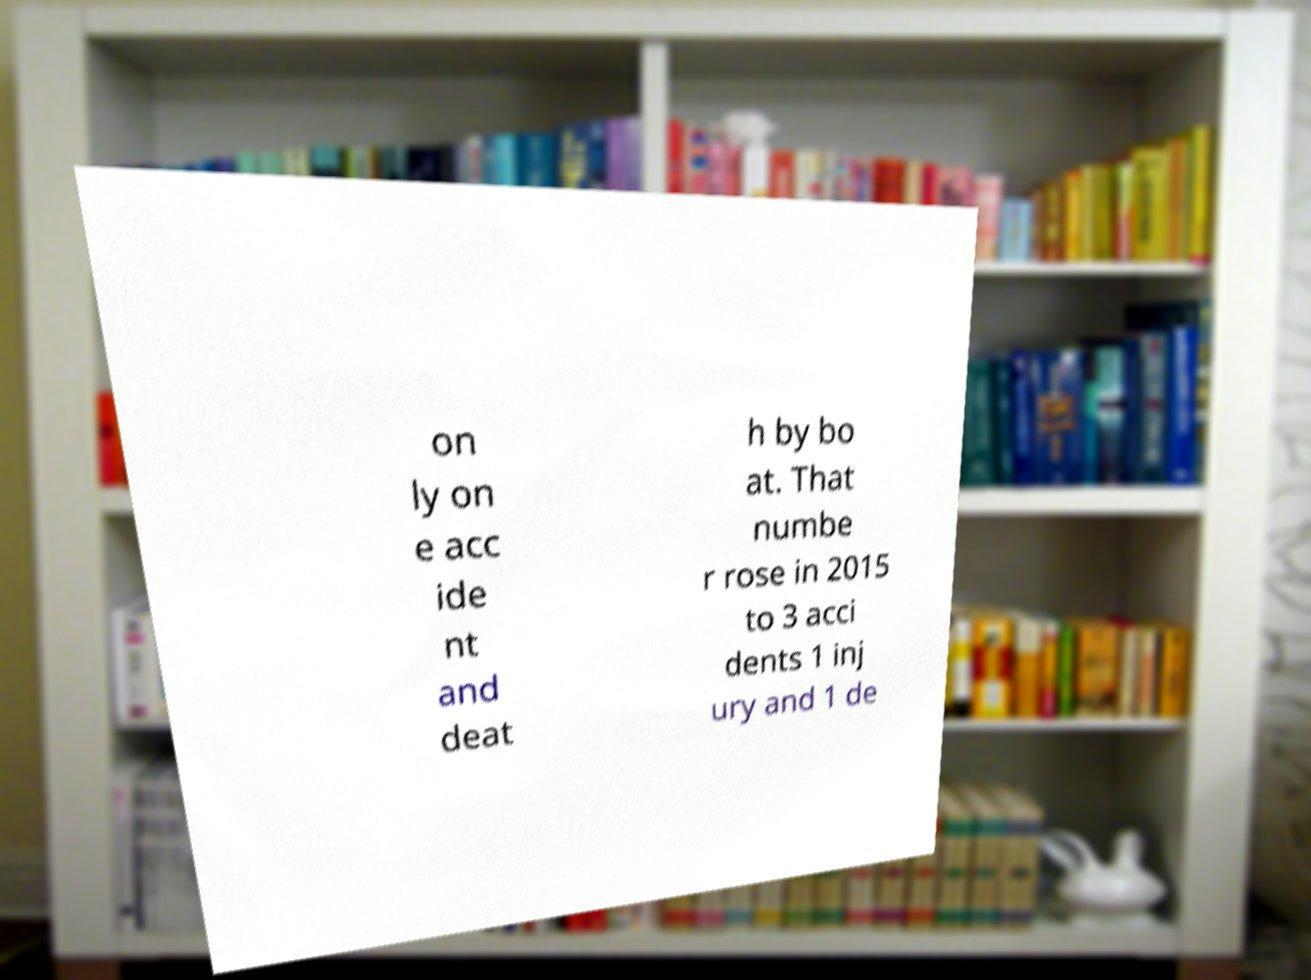Can you accurately transcribe the text from the provided image for me? on ly on e acc ide nt and deat h by bo at. That numbe r rose in 2015 to 3 acci dents 1 inj ury and 1 de 